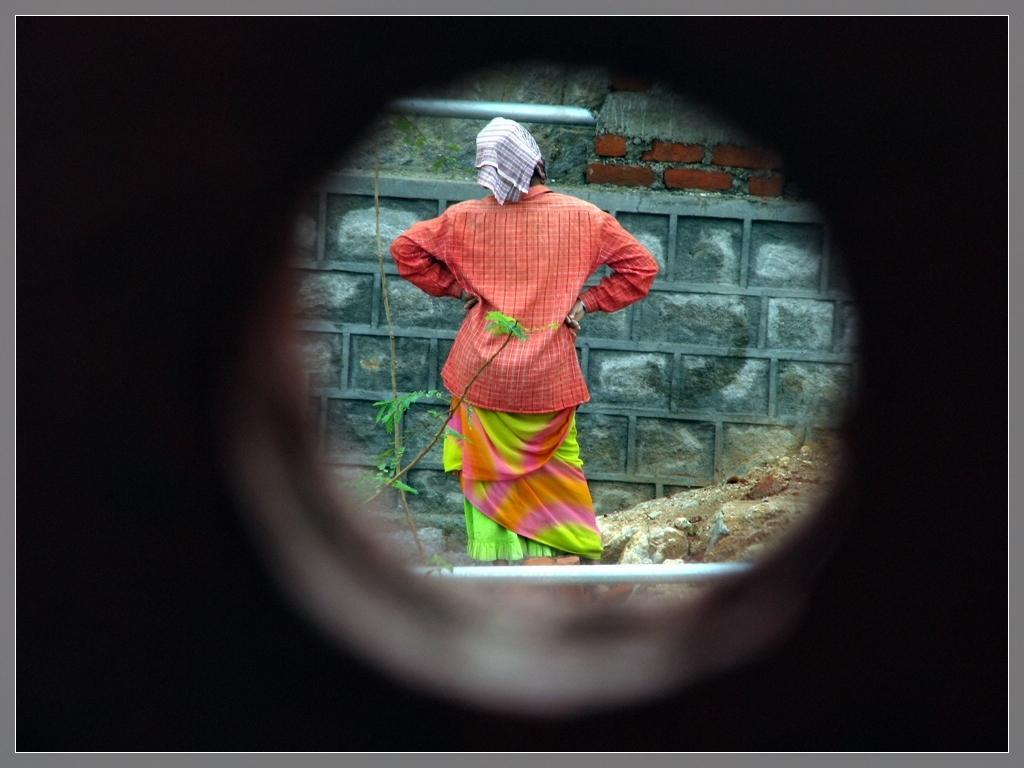In one or two sentences, can you explain what this image depicts? In this image we can see one woman standing near the wall, two poles, some stones, some sand and some plants. 